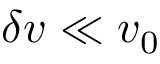Convert formula to latex. <formula><loc_0><loc_0><loc_500><loc_500>\delta v \ll v _ { 0 }</formula> 